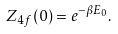Convert formula to latex. <formula><loc_0><loc_0><loc_500><loc_500>Z _ { 4 f } ( 0 ) = e ^ { - \beta E _ { 0 } } .</formula> 